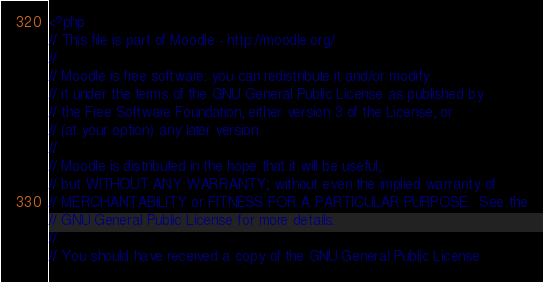<code> <loc_0><loc_0><loc_500><loc_500><_PHP_><?php
// This file is part of Moodle - http://moodle.org/
//
// Moodle is free software: you can redistribute it and/or modify
// it under the terms of the GNU General Public License as published by
// the Free Software Foundation, either version 3 of the License, or
// (at your option) any later version.
//
// Moodle is distributed in the hope that it will be useful,
// but WITHOUT ANY WARRANTY; without even the implied warranty of
// MERCHANTABILITY or FITNESS FOR A PARTICULAR PURPOSE.  See the
// GNU General Public License for more details.
//
// You should have received a copy of the GNU General Public License</code> 